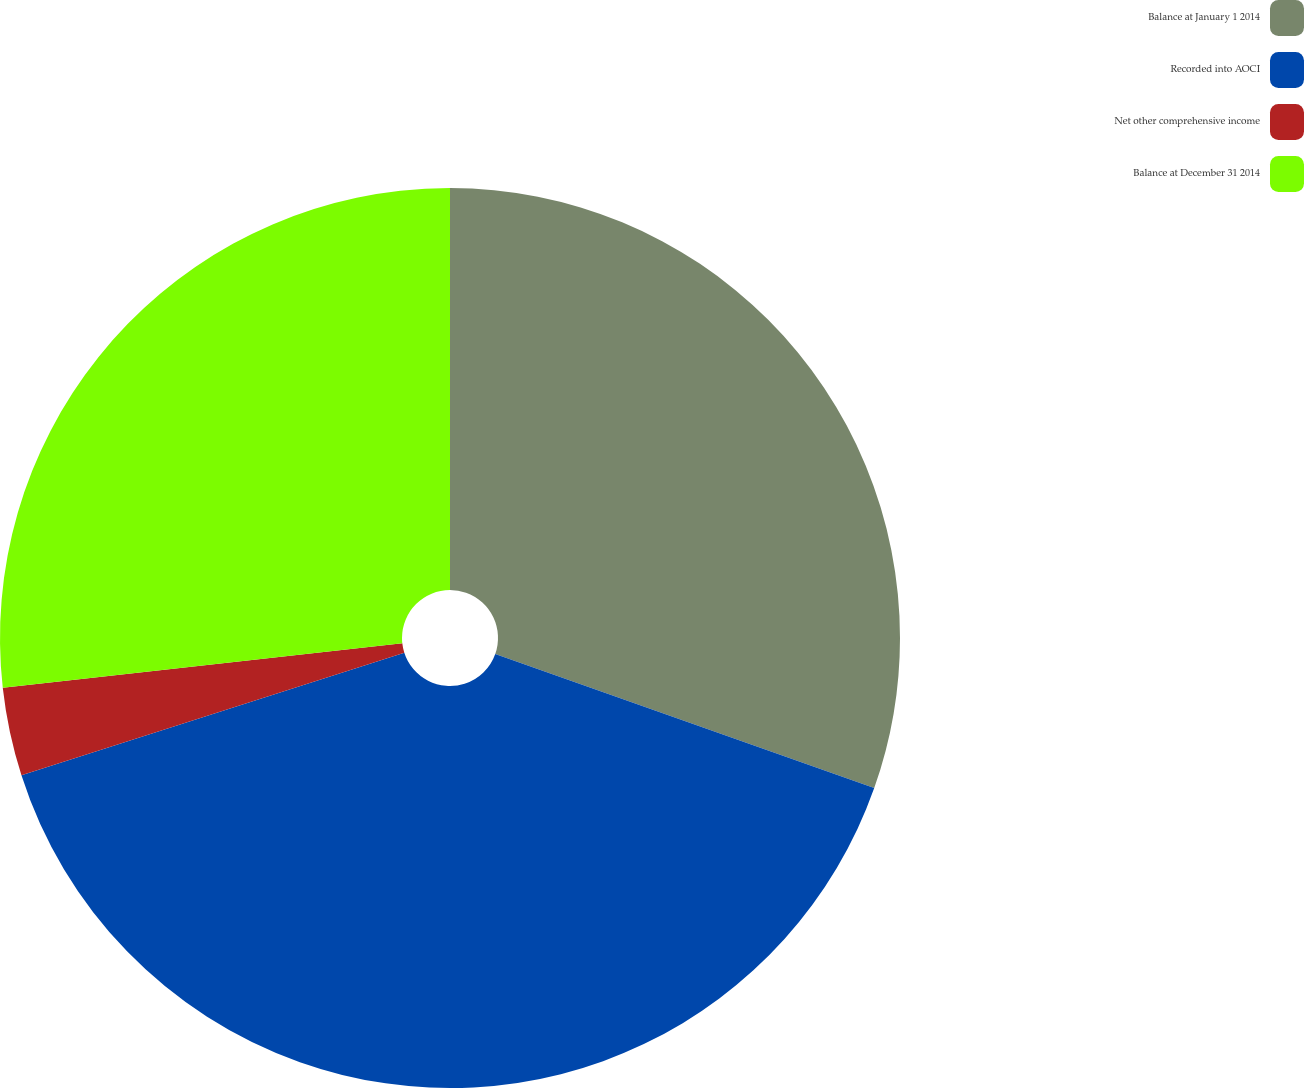Convert chart to OTSL. <chart><loc_0><loc_0><loc_500><loc_500><pie_chart><fcel>Balance at January 1 2014<fcel>Recorded into AOCI<fcel>Net other comprehensive income<fcel>Balance at December 31 2014<nl><fcel>30.41%<fcel>39.65%<fcel>3.17%<fcel>26.76%<nl></chart> 